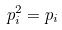<formula> <loc_0><loc_0><loc_500><loc_500>p _ { i } ^ { 2 } = p _ { i }</formula> 